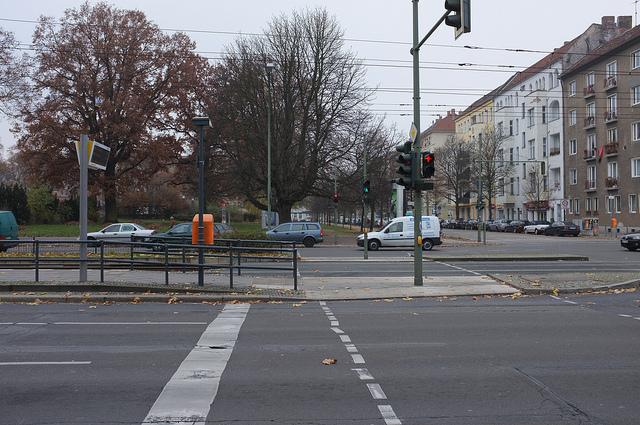Is this a busy street?
Short answer required. No. Is the picture in color?
Write a very short answer. Yes. Is it OK to cross to the median now?
Be succinct. No. Can you see a bike wheel?
Keep it brief. No. How many people in this photo?
Keep it brief. 0. Is there traffic?
Quick response, please. No. What color is the van?
Quick response, please. White. Is the man crossing the street?
Give a very brief answer. No. Are the leaves on the ground crunchy or soft?
Write a very short answer. Crunchy. Are any of the parking meters in use?
Concise answer only. Yes. Do any car's pass by this street?
Concise answer only. Yes. How many sides are on the Stop Sign?
Answer briefly. 2. Is the street clean?
Answer briefly. No. What color are the leaves on the trees?
Quick response, please. Brown. 